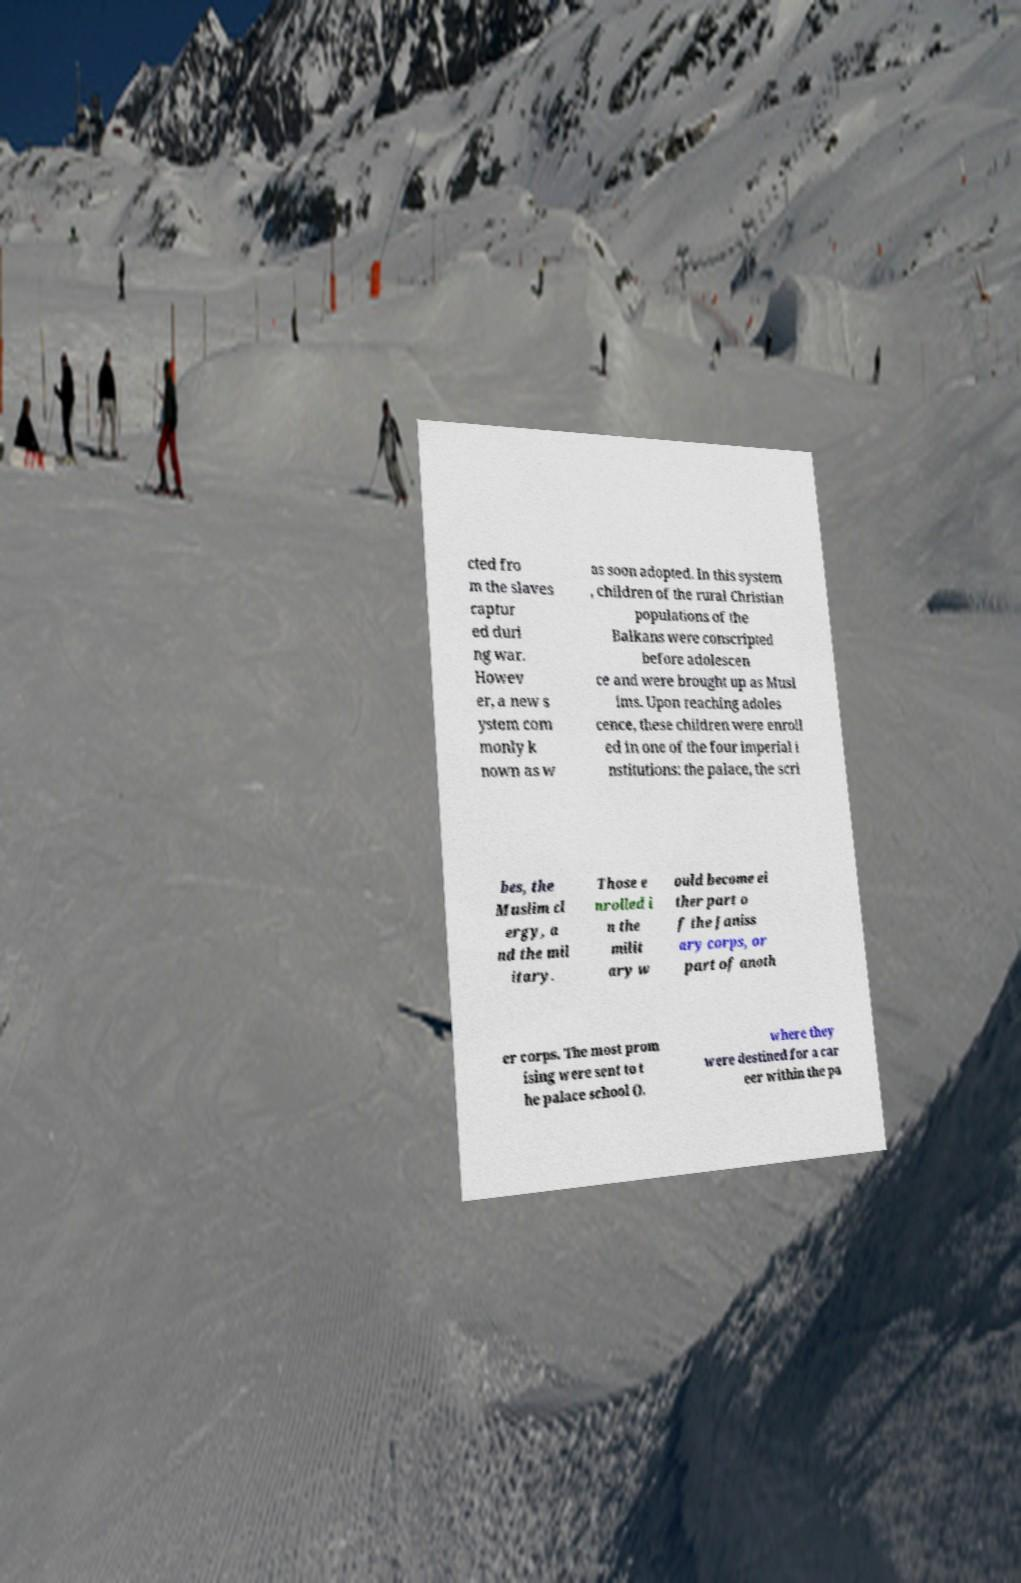I need the written content from this picture converted into text. Can you do that? cted fro m the slaves captur ed duri ng war. Howev er, a new s ystem com monly k nown as w as soon adopted. In this system , children of the rural Christian populations of the Balkans were conscripted before adolescen ce and were brought up as Musl ims. Upon reaching adoles cence, these children were enroll ed in one of the four imperial i nstitutions: the palace, the scri bes, the Muslim cl ergy, a nd the mil itary. Those e nrolled i n the milit ary w ould become ei ther part o f the Janiss ary corps, or part of anoth er corps. The most prom ising were sent to t he palace school (), where they were destined for a car eer within the pa 